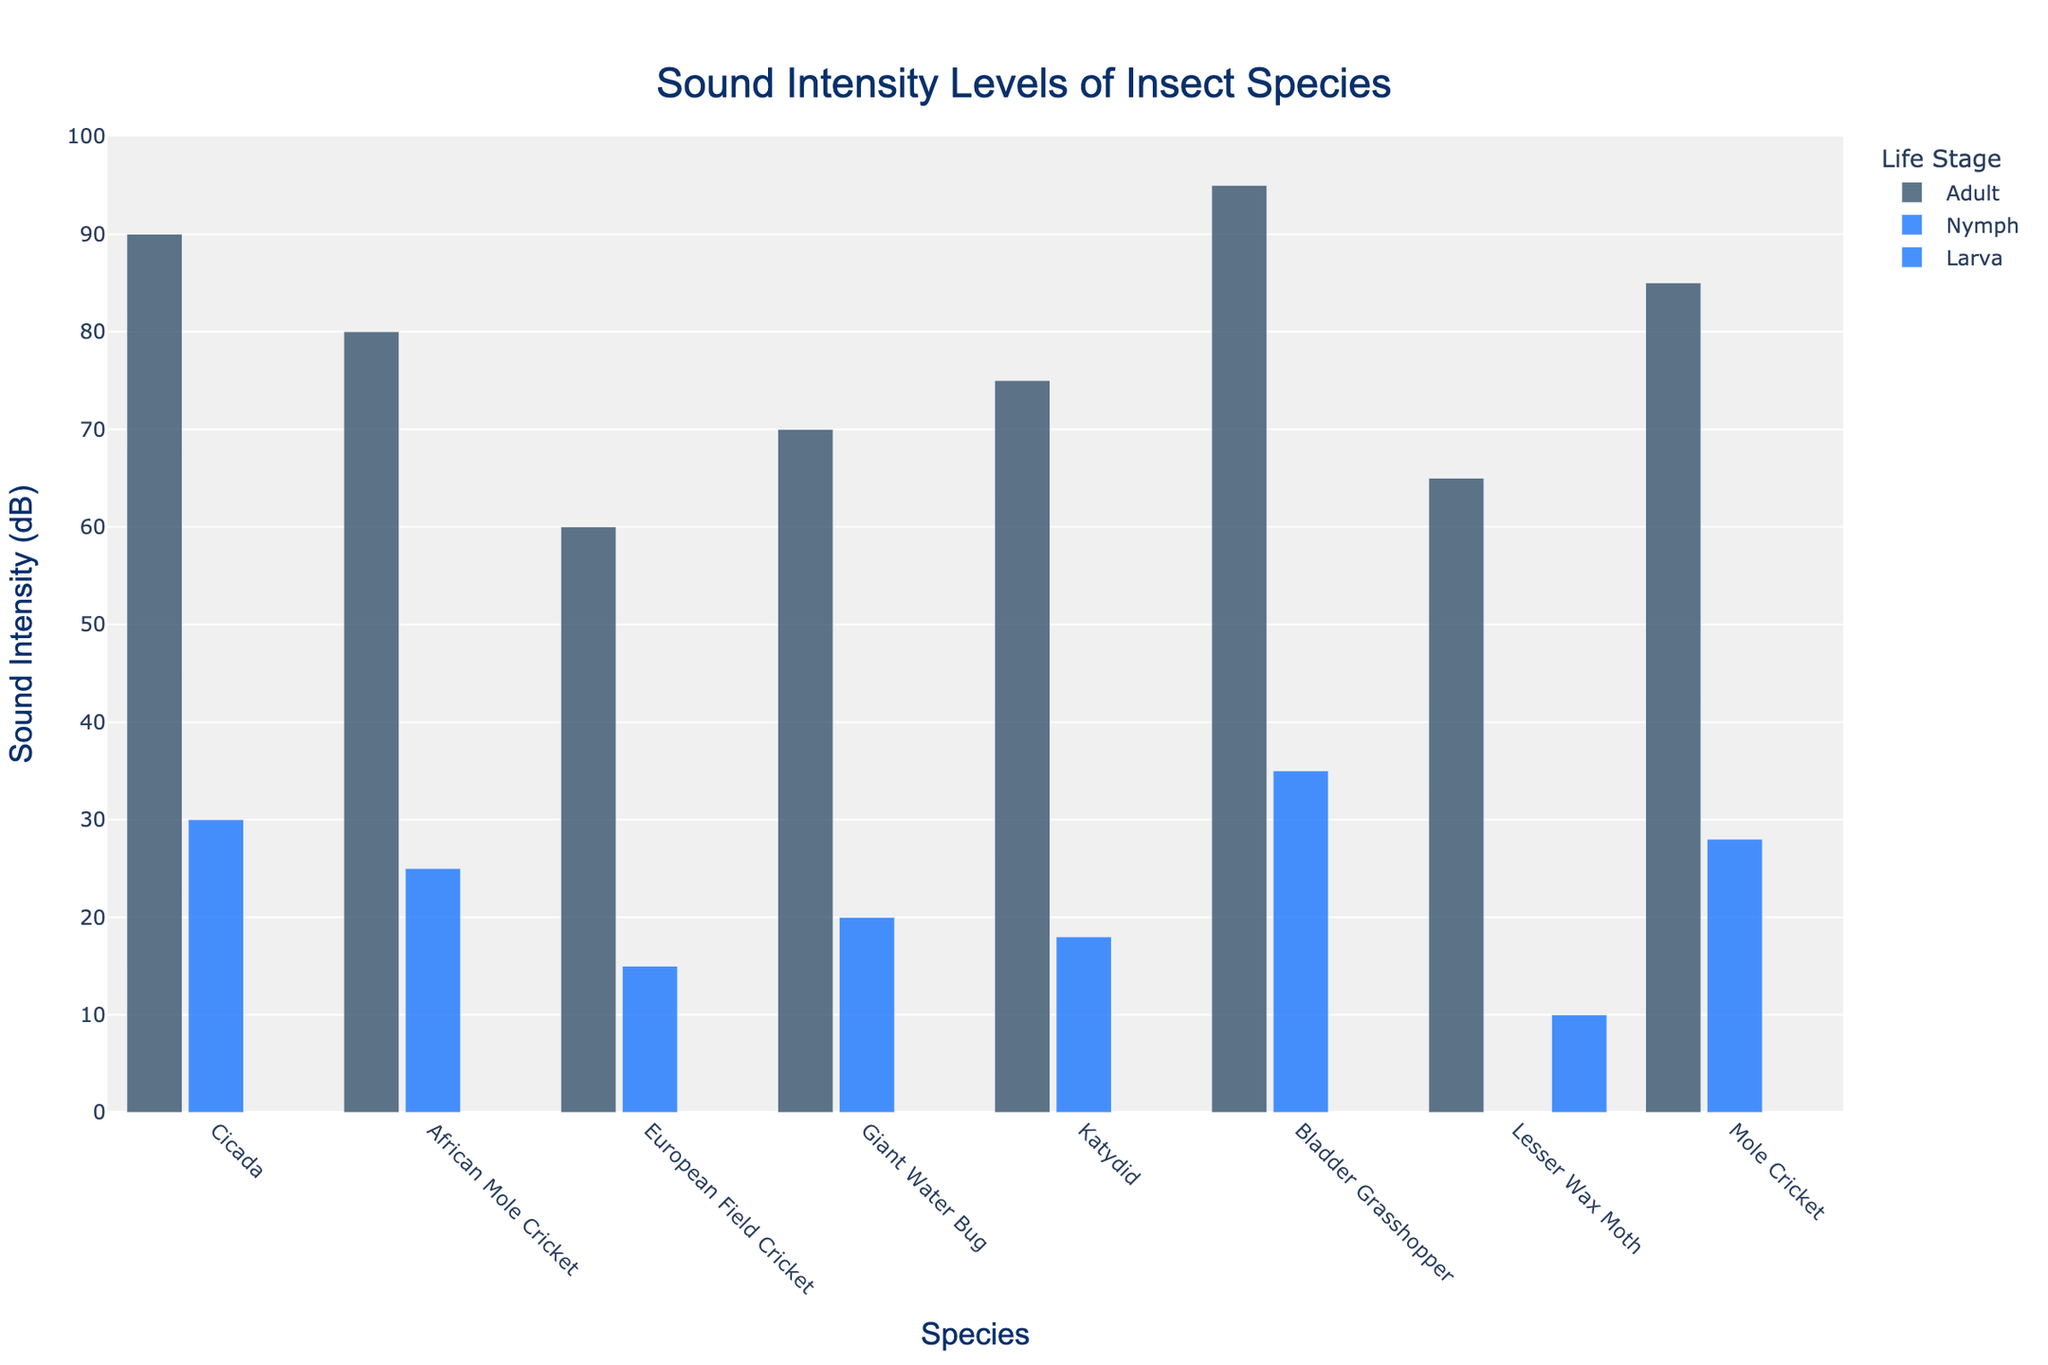What's the difference in sound intensity between the adult and nymph stages of the Cicada (Magicicada septendecim)? First, find the sound intensity levels for both the adult and nymph stages of the Cicada (Magicicada septendecim). The adult stage has a sound intensity of 90 dB, while the nymph stage has a sound intensity of 30 dB. The difference is 90 dB - 30 dB = 60 dB.
Answer: 60 dB Which insect species produces the highest sound intensity in its adult stage? Identify the sound intensity levels for all adult species in the chart. The species with the highest sound intensity in the adult stage is the Bladder Grasshopper (Bullacris membracioides) at 95 dB.
Answer: Bladder Grasshopper (Bullacris membracioides) Which insect has the lowest sound intensity in its juvenile life stage (nymph/larva)? Check the sound intensity levels for all nymph and larva stages. The Lesser Wax Moth (Achroia grisella) in the larva stage has the lowest sound intensity at 10 dB.
Answer: Lesser Wax Moth (Achroia grisella) What's the average sound intensity level of all insect species in their nymph stage? Sum the sound intensity levels of all nymph stages: 30 dB (Cicada) + 25 dB (African Mole Cricket) + 15 dB (European Field Cricket) + 20 dB (Giant Water Bug) + 18 dB (Katydid) + 35 dB (Bladder Grasshopper) + 28 dB (Mole Cricket). There are 7 data points. The average is (30 + 25 + 15 + 20 + 18 + 35 + 28)/7 = 171/7 ≈ 24.43 dB.
Answer: 24.43 dB Are there more species with sound intensity levels above 80 dB in the adult stage or in the nymph stage? Identify the sound intensity levels above 80 dB for both stages. In the adult stage, there are 3 species: Cicada (90 dB), Bladder Grasshopper (95 dB), and Mole Cricket (85 dB). In the nymph stage, there are no species with sound intensity levels above 80 dB.
Answer: Adult stage How much louder is the adult Giant Water Bug (Lethocerus indicus) compared to its nymph stage? Find the sound intensity levels for both stages of the Giant Water Bug. The adult stage has a sound intensity of 70 dB, and the nymph stage has a sound intensity of 20 dB. The difference is 70 dB - 20 dB = 50 dB.
Answer: 50 dB Which life stage has a greater variety in sound intensity levels, adults or nymphs/larvae? Compare the range of sound intensities in both stages. Adults range from 60 dB (European Field Cricket) to 95 dB (Bladder Grasshopper), which is 95 - 60 = 35 dB. Nymphs/Larvae range from 10 dB (Lesser Wax Moth) to 35 dB (Bladder Grasshopper), which is 35 - 10 = 25 dB. Adults have a greater variety.
Answer: Adults What's the combined sound intensity of the nymphs of African Mole Cricket (Gryllotalpa africana) and the katydid (Pterophylla camellifolia)? Add the sound intensity levels of the nymph stage for both species. African Mole Cricket has 25 dB, and Katydid has 18 dB. The combined intensity is 25 + 18 = 43 dB.
Answer: 43 dB Which insect species shows the largest increase in sound intensity from its juvenile to adult stage? Calculate the difference in sound intensity between the juvenile and adult stages for each species: (Cicada: 90 - 30 = 60 dB), (African Mole Cricket: 80 - 25 = 55 dB), (European Field Cricket: 60 - 15 = 45 dB), (Giant Water Bug: 70 - 20 = 50 dB), (Katydid: 75 - 18 = 57 dB), (Bladder Grasshopper: 95 - 35 = 60 dB), (Lesser Wax Moth: 65 - 10 = 55 dB), (Mole Cricket: 85 - 28 = 57 dB). The largest increase is shown by the Cicada and the Bladder Grasshopper (both 60 dB).
Answer: Cicada and Bladder Grasshopper 